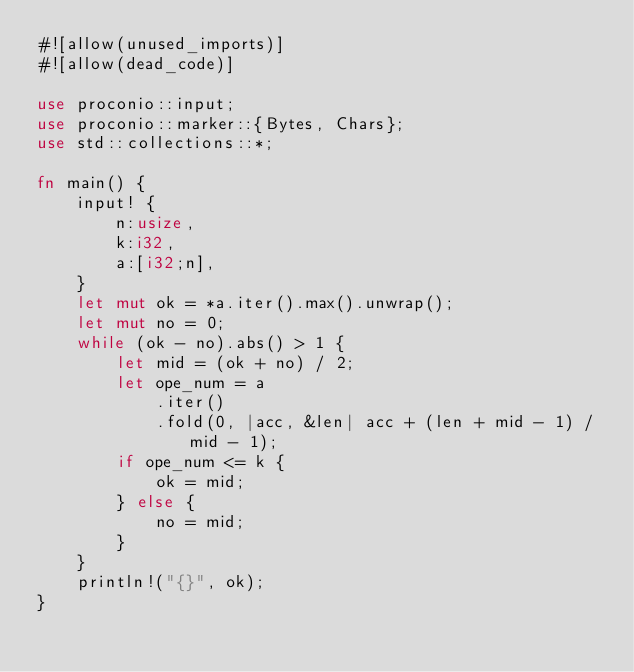Convert code to text. <code><loc_0><loc_0><loc_500><loc_500><_Rust_>#![allow(unused_imports)]
#![allow(dead_code)]

use proconio::input;
use proconio::marker::{Bytes, Chars};
use std::collections::*;

fn main() {
    input! {
        n:usize,
        k:i32,
        a:[i32;n],
    }
    let mut ok = *a.iter().max().unwrap();
    let mut no = 0;
    while (ok - no).abs() > 1 {
        let mid = (ok + no) / 2;
        let ope_num = a
            .iter()
            .fold(0, |acc, &len| acc + (len + mid - 1) / mid - 1);
        if ope_num <= k {
            ok = mid;
        } else {
            no = mid;
        }
    }
    println!("{}", ok);
}</code> 